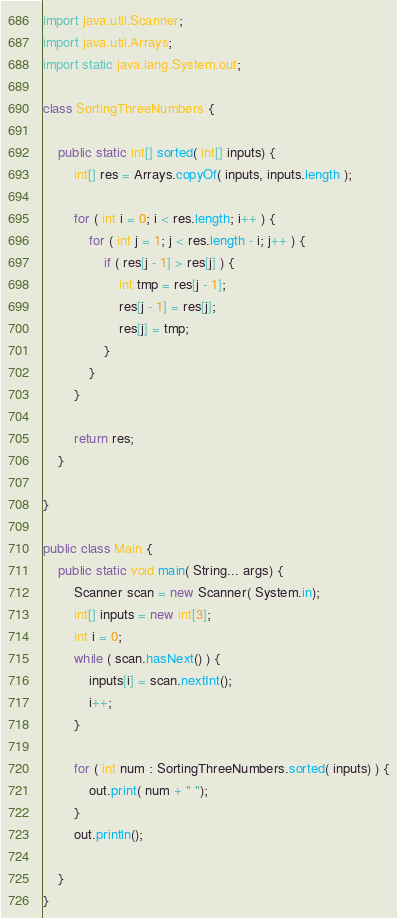<code> <loc_0><loc_0><loc_500><loc_500><_Java_>import java.util.Scanner;
import java.util.Arrays;
import static java.lang.System.out;

class SortingThreeNumbers {

    public static int[] sorted( int[] inputs) {
        int[] res = Arrays.copyOf( inputs, inputs.length );

        for ( int i = 0; i < res.length; i++ ) {
            for ( int j = 1; j < res.length - i; j++ ) {
                if ( res[j - 1] > res[j] ) {
                    int tmp = res[j - 1];
                    res[j - 1] = res[j];
                    res[j] = tmp;
                }
            }
        }

        return res;
    }

}

public class Main {
    public static void main( String... args) {
        Scanner scan = new Scanner( System.in);
        int[] inputs = new int[3];
        int i = 0;
        while ( scan.hasNext() ) {
            inputs[i] = scan.nextInt();
            i++;
        }

        for ( int num : SortingThreeNumbers.sorted( inputs) ) {
            out.print( num + " ");
        }
        out.println();

    }
}</code> 